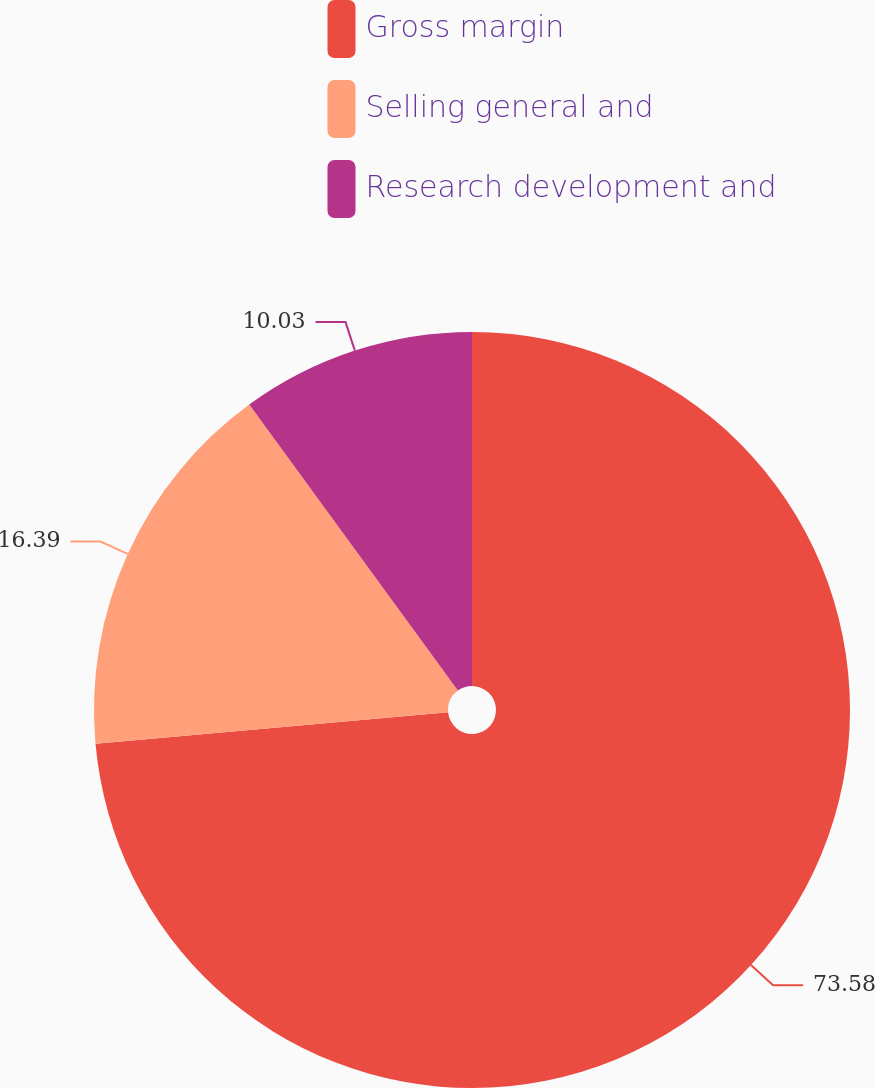Convert chart. <chart><loc_0><loc_0><loc_500><loc_500><pie_chart><fcel>Gross margin<fcel>Selling general and<fcel>Research development and<nl><fcel>73.58%<fcel>16.39%<fcel>10.03%<nl></chart> 